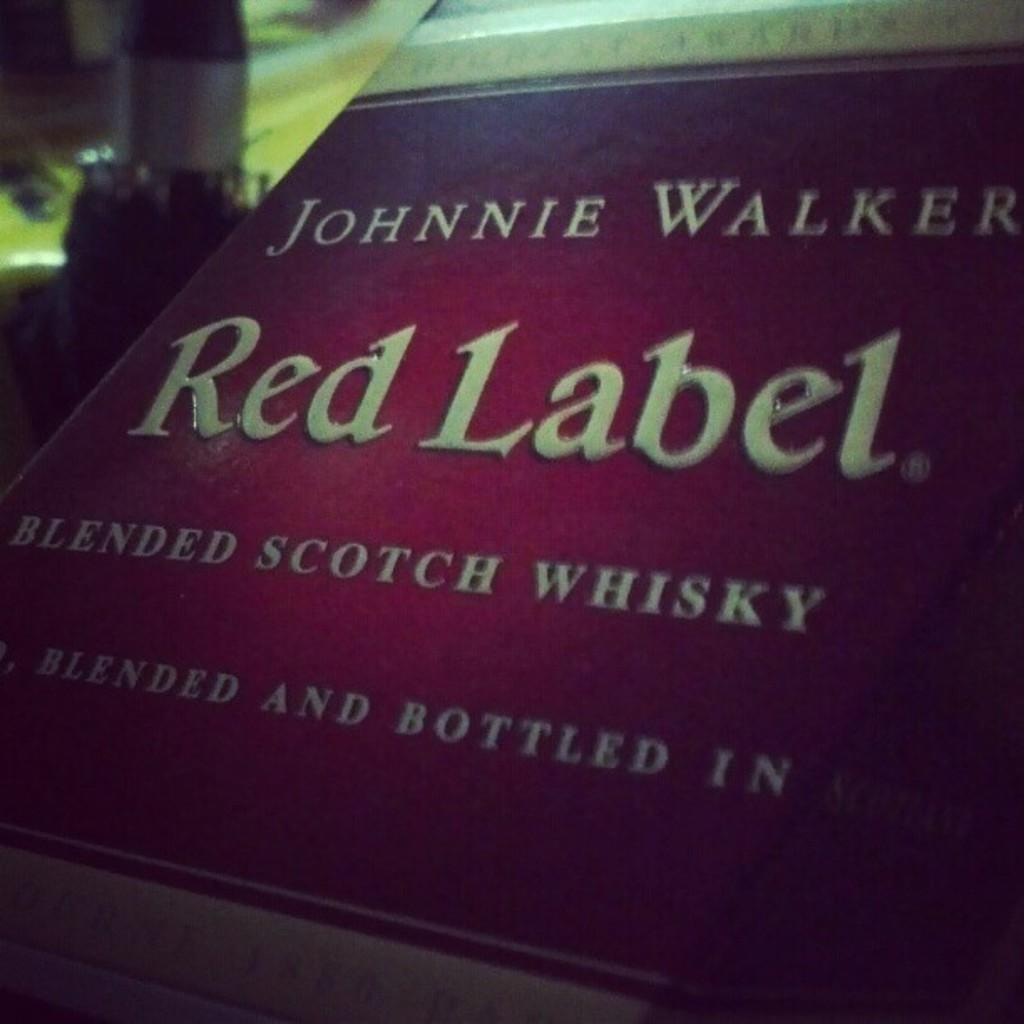Provide a one-sentence caption for the provided image. A label from Red Label Blended Scotch Whisky is displayed. 